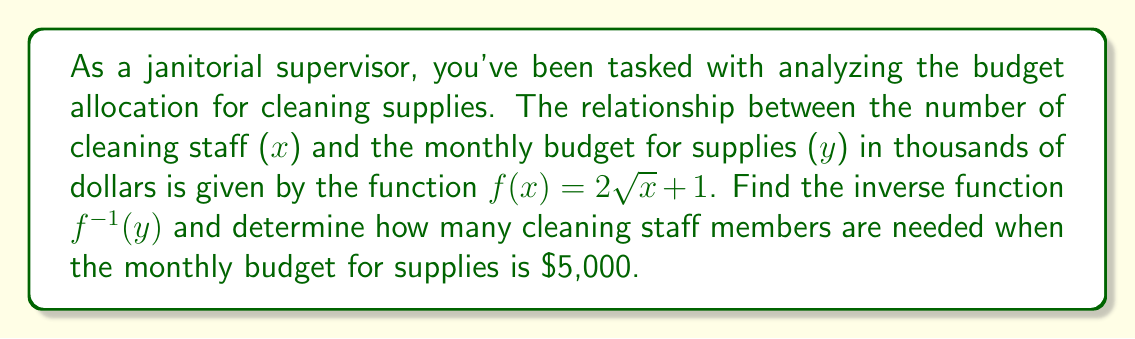Show me your answer to this math problem. To find the inverse function and solve this problem, we'll follow these steps:

1) First, let's write the original function:
   $y = f(x) = 2\sqrt{x} + 1$

2) To find the inverse, we'll swap x and y:
   $x = 2\sqrt{y} + 1$

3) Now, we need to solve this equation for y:
   $x - 1 = 2\sqrt{y}$
   $\frac{x - 1}{2} = \sqrt{y}$

4) Square both sides:
   $(\frac{x - 1}{2})^2 = y$

5) Simplify:
   $\frac{(x - 1)^2}{4} = y$

6) This is our inverse function. We can write it as:
   $f^{-1}(x) = \frac{(x - 1)^2}{4}$

7) Now, to find how many cleaning staff are needed when the budget is $5,000, we'll use x = 5 (since the budget was given in thousands):
   $f^{-1}(5) = \frac{(5 - 1)^2}{4} = \frac{16}{4} = 4$

Therefore, 4 cleaning staff members are needed when the monthly budget for supplies is $5,000.
Answer: The inverse function is $f^{-1}(x) = \frac{(x - 1)^2}{4}$, and 4 cleaning staff members are needed when the monthly budget for supplies is $5,000. 